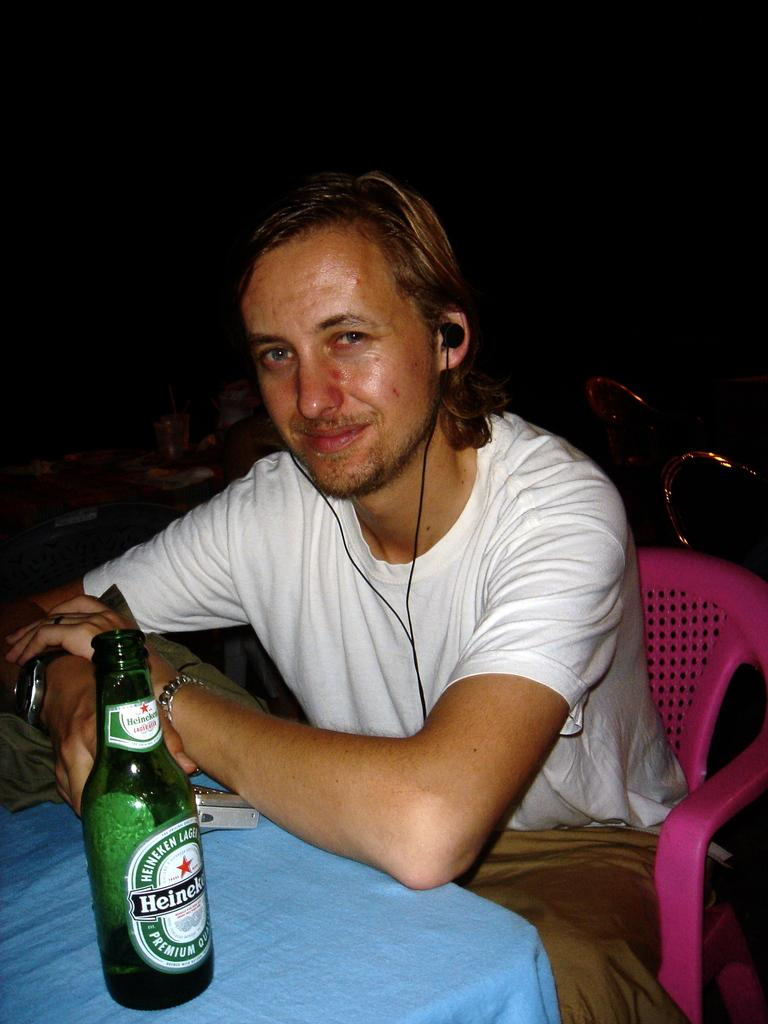What is the man in the image doing? The man is sitting on a chair in the image. What can be seen connected to the man? The man is using earphones. What objects are on the table in the image? There is a bottle and a cloth on the table. What type of beef is being used as bait in the image? There is no beef or bait present in the image. 